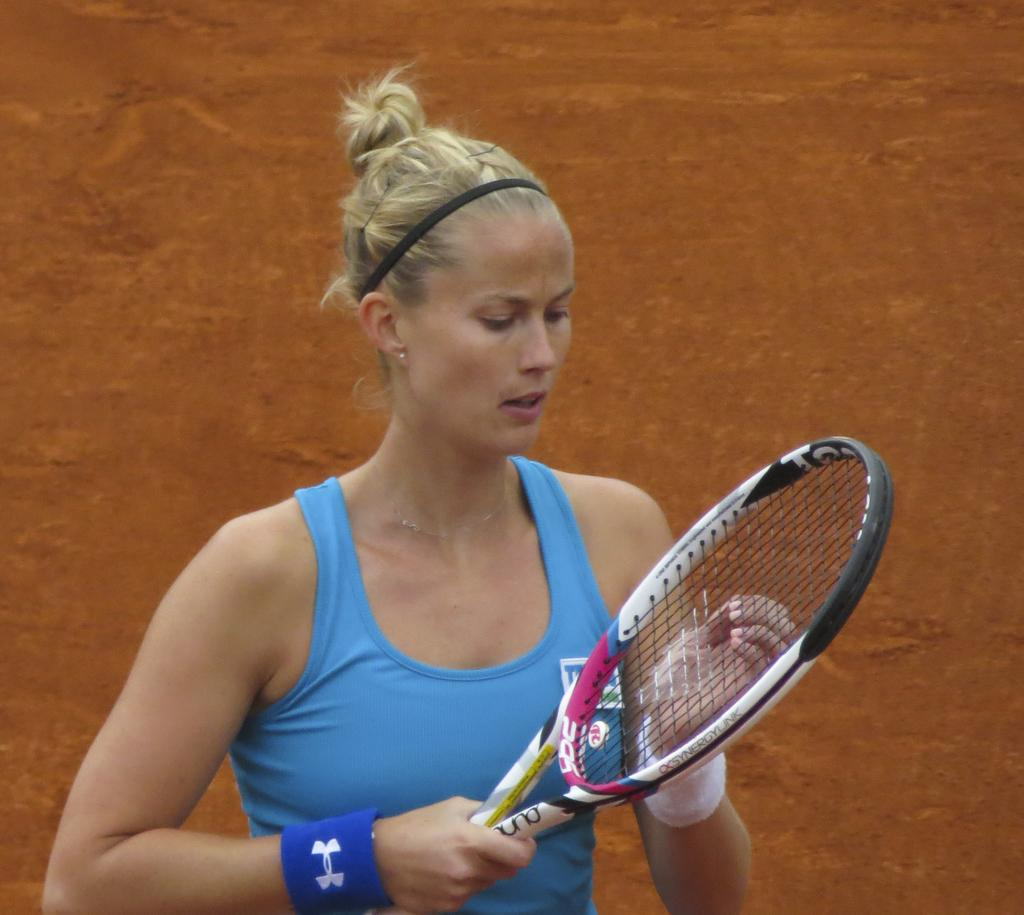Who is present in the image? There is a woman in the image. What is the woman holding in the image? The woman is holding a racket. Is there a boat in the image? No, there is no boat present in the image. 